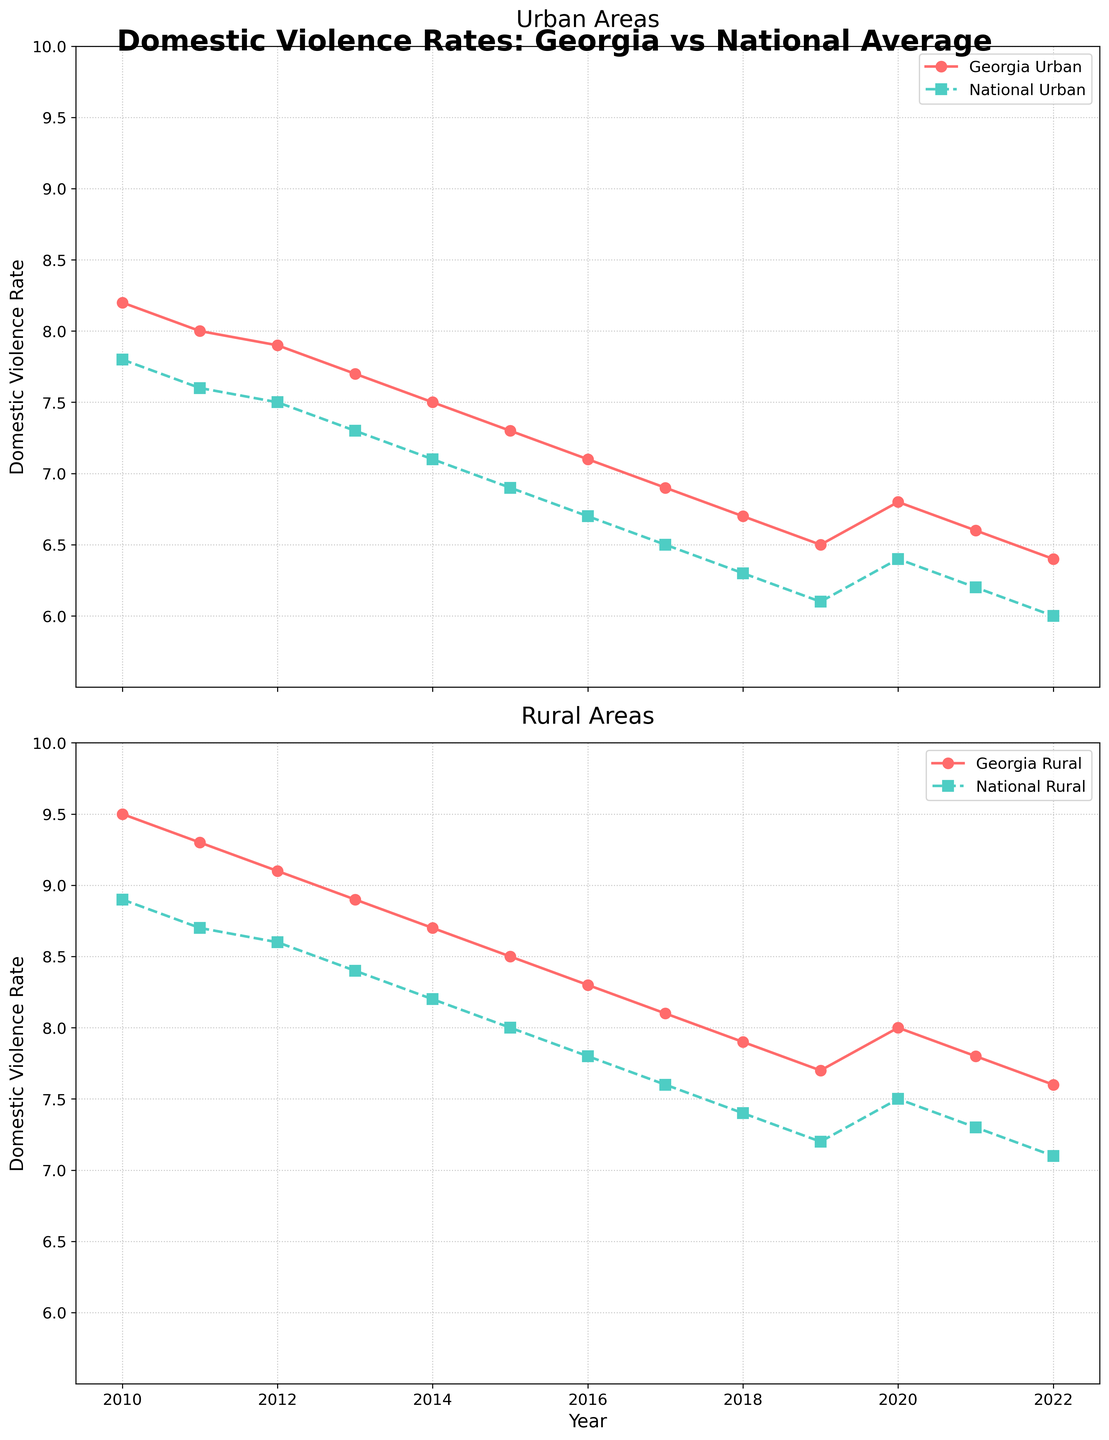Which area (urban or rural) has consistently higher domestic violence rates in Georgia from 2010 to 2022? Looking at the two plots, the Georgia Rural line is always above the Georgia Urban line. Hence, the rural areas in Georgia have consistently higher domestic violence rates compared to the urban areas.
Answer: Rural areas How did domestic violence rates in Georgia Urban areas change from 2010 to 2022? From 2010 to 2022, the Georgia Urban line shows a general downward trend, starting from around 8.2 in 2010 and dropping to around 6.4 in 2022.
Answer: Decreased In which year did the domestic violence rate for National Urban areas decline to below 7.5? Observing the National Urban line, it dropped below 7.5 between 2011 and 2012.
Answer: 2012 What is the difference between the domestic violence rates in Georgia Rural and National Rural areas in 2014? In 2014, the rate for Georgia Rural is 8.7 and for National Rural is 8.2. The difference is 8.7 - 8.2 = 0.5.
Answer: 0.5 Which had a greater decline from 2010 to 2022: Georgia Urban or National Urban domestic violence rates? Georgia Urban dropped from 8.2 in 2010 to 6.4 in 2022, a decline of 8.2 - 6.4 = 1.8. National Urban dropped from 7.8 in 2010 to 6.0 in 2022, a decline of 7.8 - 6.0 = 1.8. Both areas experienced the same decline.
Answer: Same When did the domestic violence rates for Georgia Urban and National Urban become nearly equal? Around 2017, the two lines for Georgia Urban and National Urban are very close, both hovering around 6.9 to 6.5.
Answer: 2017 Compare the rate of change in domestic violence rates in Georgia Rural areas from 2010 to 2022 versus National Rural areas over the same period. Georgia Rural declined from 9.5 in 2010 to 7.6 in 2022, a decrease of 9.5 - 7.6 = 1.9. National Rural declined from 8.9 in 2010 to 7.1 in 2022, a decrease of 8.9 - 7.1 = 1.8. Thus, Georgia Rural decreased slightly more.
Answer: Georgia Rural Is there any year where the domestic violence rate in Georgia Urban areas is higher than the National Urban areas? Observing the graph, in all years from 2010 to 2022, the line for Georgia Urban is above the line for National Urban, indicating Georgia Urban always has higher rates.
Answer: No In which year did the rate for Georgia Rural areas see a peak value within the provided timeframe? The highest point for Georgia Rural is at the very beginning of the timeline in 2010 with a value of around 9.5.
Answer: 2010 